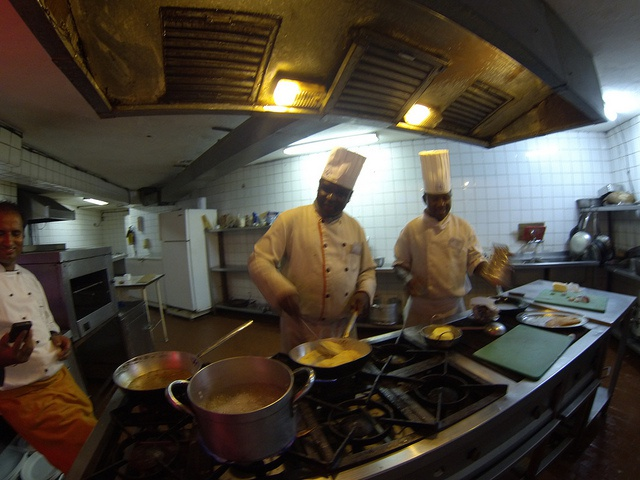Describe the objects in this image and their specific colors. I can see oven in maroon, black, olive, and gray tones, people in maroon, black, and gray tones, people in maroon, black, and olive tones, oven in maroon, black, gray, and darkgray tones, and refrigerator in maroon, gray, and black tones in this image. 